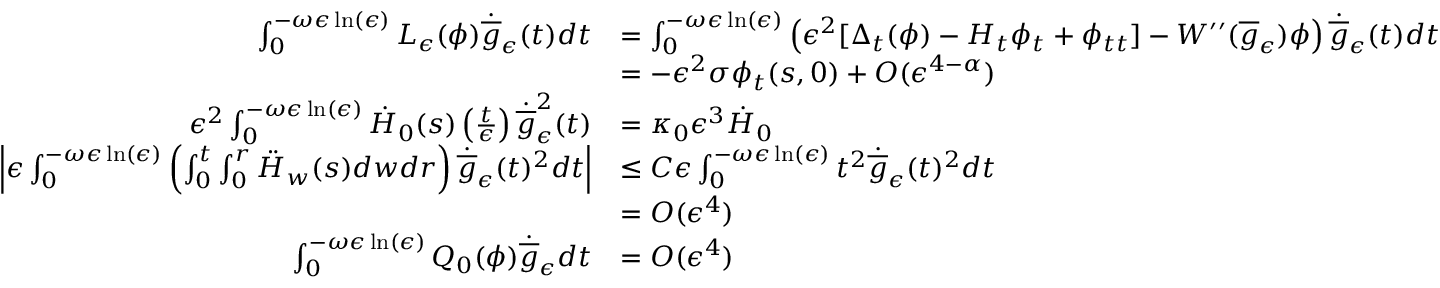<formula> <loc_0><loc_0><loc_500><loc_500>\begin{array} { r l } { \int _ { 0 } ^ { - \omega \epsilon \ln ( \epsilon ) } L _ { \epsilon } ( \phi ) \dot { \overline { g } } _ { \epsilon } ( t ) d t } & { = \int _ { 0 } ^ { - \omega \epsilon \ln ( \epsilon ) } \left ( \epsilon ^ { 2 } [ \Delta _ { t } ( \phi ) - H _ { t } \phi _ { t } + \phi _ { t t } ] - W ^ { \prime \prime } ( \overline { g } _ { \epsilon } ) \phi \right ) \dot { \overline { g } } _ { \epsilon } ( t ) d t } \\ & { = - \epsilon ^ { 2 } \sigma \phi _ { t } ( s , 0 ) + O ( \epsilon ^ { 4 - \alpha } ) } \\ { \epsilon ^ { 2 } \int _ { 0 } ^ { - \omega \epsilon \ln ( \epsilon ) } \dot { H } _ { 0 } ( s ) \left ( \frac { t } { \epsilon } \right ) \dot { \overline { g } } _ { \epsilon } ^ { 2 } ( t ) } & { = \kappa _ { 0 } \epsilon ^ { 3 } \dot { H } _ { 0 } } \\ { \left | \epsilon \int _ { 0 } ^ { - \omega \epsilon \ln ( \epsilon ) } \left ( \int _ { 0 } ^ { t } \int _ { 0 } ^ { r } \ddot { H } _ { w } ( s ) d w d r \right ) \dot { \overline { g } } _ { \epsilon } ( t ) ^ { 2 } d t \right | } & { \leq C \epsilon \int _ { 0 } ^ { - \omega \epsilon \ln ( \epsilon ) } t ^ { 2 } \dot { \overline { g } } _ { \epsilon } ( t ) ^ { 2 } d t } \\ & { = O ( \epsilon ^ { 4 } ) } \\ { \int _ { 0 } ^ { - \omega \epsilon \ln ( \epsilon ) } Q _ { 0 } ( \phi ) \dot { \overline { g } } _ { \epsilon } d t } & { = O ( \epsilon ^ { 4 } ) } \end{array}</formula> 